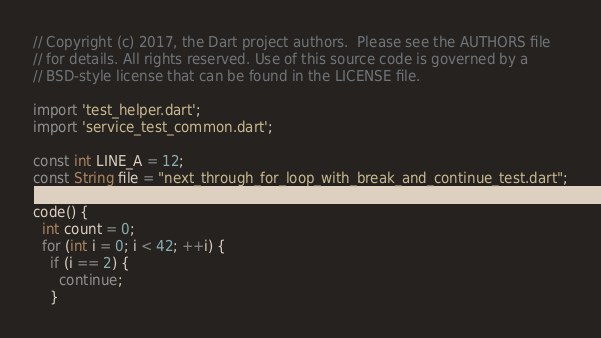Convert code to text. <code><loc_0><loc_0><loc_500><loc_500><_Dart_>// Copyright (c) 2017, the Dart project authors.  Please see the AUTHORS file
// for details. All rights reserved. Use of this source code is governed by a
// BSD-style license that can be found in the LICENSE file.

import 'test_helper.dart';
import 'service_test_common.dart';

const int LINE_A = 12;
const String file = "next_through_for_loop_with_break_and_continue_test.dart";

code() {
  int count = 0;
  for (int i = 0; i < 42; ++i) {
    if (i == 2) {
      continue;
    }</code> 